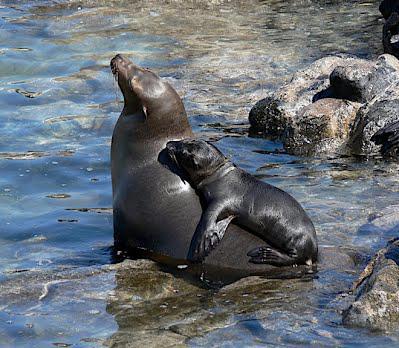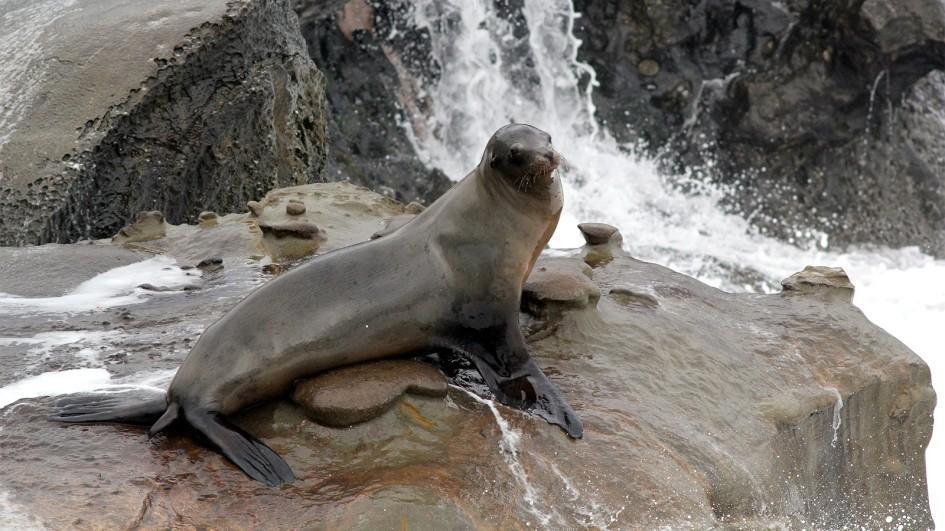The first image is the image on the left, the second image is the image on the right. Evaluate the accuracy of this statement regarding the images: "There is exactly one seal sitting on a rock in the image on the right.". Is it true? Answer yes or no. Yes. 